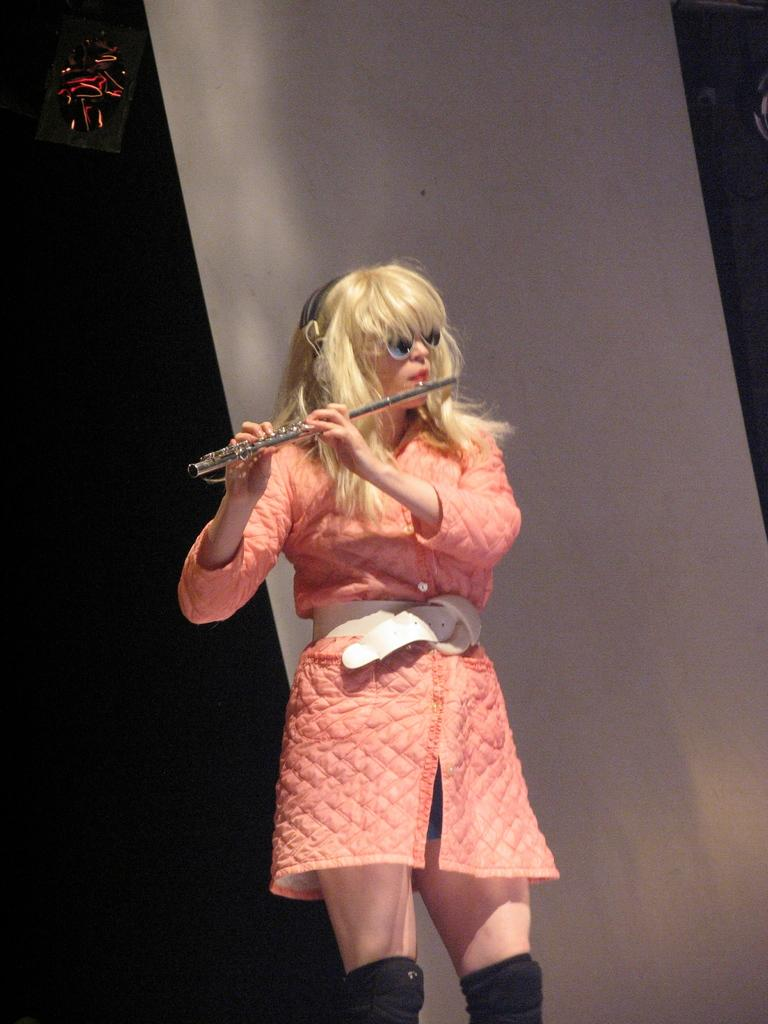What is the person in the image doing? The person is standing in the image and holding a flute. What type of accessory is the person wearing? The person is wearing goggles. What color is the dress the person is wearing? The person is wearing an orange dress. What type of cable can be seen in the image? There is no cable present in the image. What sense is the person using to play the flute? The image does not provide information about which sense the person is using to play the flute. 